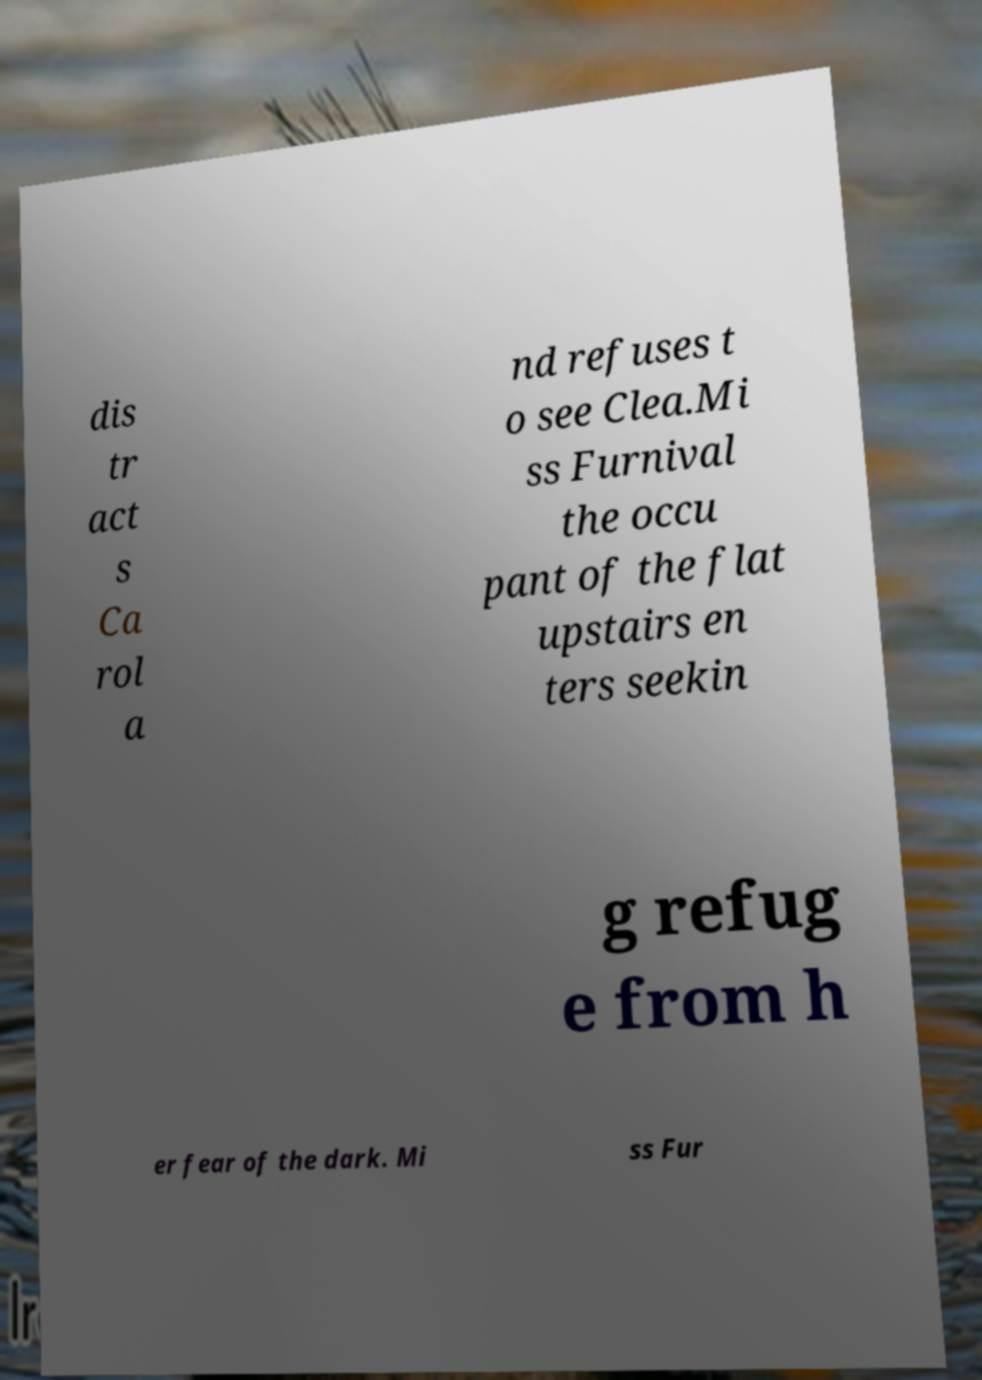For documentation purposes, I need the text within this image transcribed. Could you provide that? dis tr act s Ca rol a nd refuses t o see Clea.Mi ss Furnival the occu pant of the flat upstairs en ters seekin g refug e from h er fear of the dark. Mi ss Fur 